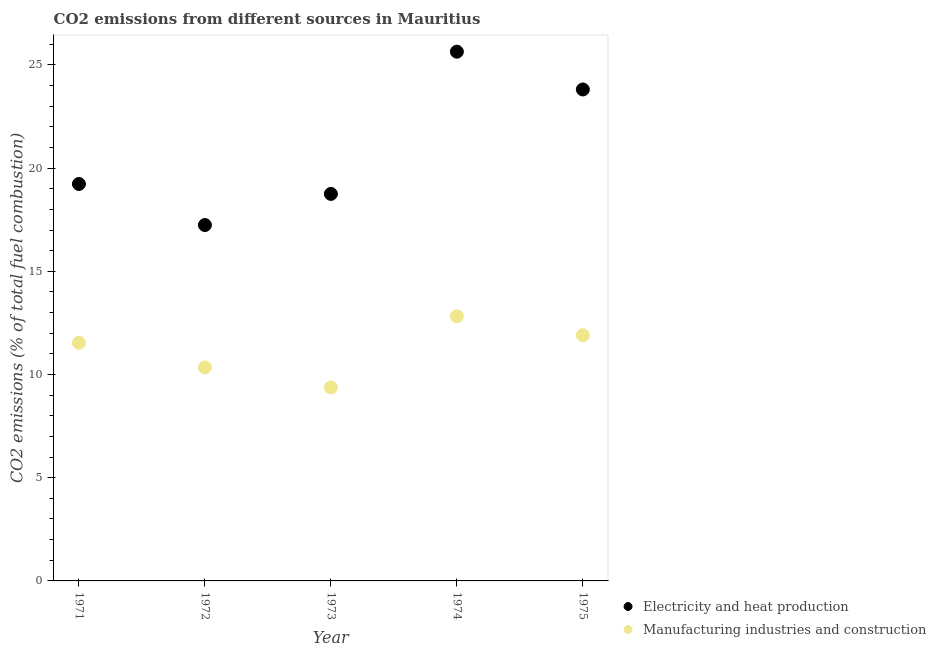How many different coloured dotlines are there?
Make the answer very short. 2. What is the co2 emissions due to manufacturing industries in 1972?
Ensure brevity in your answer.  10.34. Across all years, what is the maximum co2 emissions due to electricity and heat production?
Provide a succinct answer. 25.64. Across all years, what is the minimum co2 emissions due to electricity and heat production?
Ensure brevity in your answer.  17.24. In which year was the co2 emissions due to manufacturing industries maximum?
Give a very brief answer. 1974. What is the total co2 emissions due to electricity and heat production in the graph?
Offer a terse response. 104.67. What is the difference between the co2 emissions due to manufacturing industries in 1971 and that in 1975?
Give a very brief answer. -0.37. What is the difference between the co2 emissions due to manufacturing industries in 1974 and the co2 emissions due to electricity and heat production in 1971?
Provide a succinct answer. -6.41. What is the average co2 emissions due to electricity and heat production per year?
Your answer should be very brief. 20.93. In the year 1974, what is the difference between the co2 emissions due to electricity and heat production and co2 emissions due to manufacturing industries?
Your response must be concise. 12.82. In how many years, is the co2 emissions due to manufacturing industries greater than 17 %?
Your answer should be compact. 0. What is the ratio of the co2 emissions due to electricity and heat production in 1971 to that in 1975?
Offer a very short reply. 0.81. Is the difference between the co2 emissions due to electricity and heat production in 1972 and 1973 greater than the difference between the co2 emissions due to manufacturing industries in 1972 and 1973?
Provide a short and direct response. No. What is the difference between the highest and the second highest co2 emissions due to manufacturing industries?
Make the answer very short. 0.92. What is the difference between the highest and the lowest co2 emissions due to manufacturing industries?
Provide a short and direct response. 3.45. In how many years, is the co2 emissions due to manufacturing industries greater than the average co2 emissions due to manufacturing industries taken over all years?
Ensure brevity in your answer.  3. Is the co2 emissions due to manufacturing industries strictly greater than the co2 emissions due to electricity and heat production over the years?
Ensure brevity in your answer.  No. How many dotlines are there?
Keep it short and to the point. 2. How many years are there in the graph?
Keep it short and to the point. 5. What is the title of the graph?
Your answer should be compact. CO2 emissions from different sources in Mauritius. What is the label or title of the Y-axis?
Provide a short and direct response. CO2 emissions (% of total fuel combustion). What is the CO2 emissions (% of total fuel combustion) of Electricity and heat production in 1971?
Provide a short and direct response. 19.23. What is the CO2 emissions (% of total fuel combustion) in Manufacturing industries and construction in 1971?
Keep it short and to the point. 11.54. What is the CO2 emissions (% of total fuel combustion) in Electricity and heat production in 1972?
Your answer should be compact. 17.24. What is the CO2 emissions (% of total fuel combustion) in Manufacturing industries and construction in 1972?
Make the answer very short. 10.34. What is the CO2 emissions (% of total fuel combustion) of Electricity and heat production in 1973?
Your answer should be compact. 18.75. What is the CO2 emissions (% of total fuel combustion) of Manufacturing industries and construction in 1973?
Make the answer very short. 9.38. What is the CO2 emissions (% of total fuel combustion) of Electricity and heat production in 1974?
Ensure brevity in your answer.  25.64. What is the CO2 emissions (% of total fuel combustion) of Manufacturing industries and construction in 1974?
Offer a very short reply. 12.82. What is the CO2 emissions (% of total fuel combustion) in Electricity and heat production in 1975?
Ensure brevity in your answer.  23.81. What is the CO2 emissions (% of total fuel combustion) of Manufacturing industries and construction in 1975?
Provide a succinct answer. 11.9. Across all years, what is the maximum CO2 emissions (% of total fuel combustion) of Electricity and heat production?
Give a very brief answer. 25.64. Across all years, what is the maximum CO2 emissions (% of total fuel combustion) in Manufacturing industries and construction?
Make the answer very short. 12.82. Across all years, what is the minimum CO2 emissions (% of total fuel combustion) of Electricity and heat production?
Your answer should be very brief. 17.24. Across all years, what is the minimum CO2 emissions (% of total fuel combustion) in Manufacturing industries and construction?
Keep it short and to the point. 9.38. What is the total CO2 emissions (% of total fuel combustion) of Electricity and heat production in the graph?
Your response must be concise. 104.67. What is the total CO2 emissions (% of total fuel combustion) in Manufacturing industries and construction in the graph?
Your response must be concise. 55.98. What is the difference between the CO2 emissions (% of total fuel combustion) of Electricity and heat production in 1971 and that in 1972?
Your answer should be compact. 1.99. What is the difference between the CO2 emissions (% of total fuel combustion) in Manufacturing industries and construction in 1971 and that in 1972?
Your answer should be compact. 1.19. What is the difference between the CO2 emissions (% of total fuel combustion) in Electricity and heat production in 1971 and that in 1973?
Make the answer very short. 0.48. What is the difference between the CO2 emissions (% of total fuel combustion) in Manufacturing industries and construction in 1971 and that in 1973?
Provide a succinct answer. 2.16. What is the difference between the CO2 emissions (% of total fuel combustion) of Electricity and heat production in 1971 and that in 1974?
Your answer should be compact. -6.41. What is the difference between the CO2 emissions (% of total fuel combustion) of Manufacturing industries and construction in 1971 and that in 1974?
Your answer should be very brief. -1.28. What is the difference between the CO2 emissions (% of total fuel combustion) of Electricity and heat production in 1971 and that in 1975?
Offer a terse response. -4.58. What is the difference between the CO2 emissions (% of total fuel combustion) in Manufacturing industries and construction in 1971 and that in 1975?
Keep it short and to the point. -0.37. What is the difference between the CO2 emissions (% of total fuel combustion) of Electricity and heat production in 1972 and that in 1973?
Your answer should be compact. -1.51. What is the difference between the CO2 emissions (% of total fuel combustion) in Manufacturing industries and construction in 1972 and that in 1973?
Make the answer very short. 0.97. What is the difference between the CO2 emissions (% of total fuel combustion) of Electricity and heat production in 1972 and that in 1974?
Your response must be concise. -8.4. What is the difference between the CO2 emissions (% of total fuel combustion) in Manufacturing industries and construction in 1972 and that in 1974?
Keep it short and to the point. -2.48. What is the difference between the CO2 emissions (% of total fuel combustion) in Electricity and heat production in 1972 and that in 1975?
Give a very brief answer. -6.57. What is the difference between the CO2 emissions (% of total fuel combustion) in Manufacturing industries and construction in 1972 and that in 1975?
Keep it short and to the point. -1.56. What is the difference between the CO2 emissions (% of total fuel combustion) of Electricity and heat production in 1973 and that in 1974?
Your answer should be very brief. -6.89. What is the difference between the CO2 emissions (% of total fuel combustion) of Manufacturing industries and construction in 1973 and that in 1974?
Offer a terse response. -3.45. What is the difference between the CO2 emissions (% of total fuel combustion) in Electricity and heat production in 1973 and that in 1975?
Ensure brevity in your answer.  -5.06. What is the difference between the CO2 emissions (% of total fuel combustion) in Manufacturing industries and construction in 1973 and that in 1975?
Your answer should be compact. -2.53. What is the difference between the CO2 emissions (% of total fuel combustion) of Electricity and heat production in 1974 and that in 1975?
Ensure brevity in your answer.  1.83. What is the difference between the CO2 emissions (% of total fuel combustion) in Manufacturing industries and construction in 1974 and that in 1975?
Give a very brief answer. 0.92. What is the difference between the CO2 emissions (% of total fuel combustion) in Electricity and heat production in 1971 and the CO2 emissions (% of total fuel combustion) in Manufacturing industries and construction in 1972?
Offer a very short reply. 8.89. What is the difference between the CO2 emissions (% of total fuel combustion) of Electricity and heat production in 1971 and the CO2 emissions (% of total fuel combustion) of Manufacturing industries and construction in 1973?
Keep it short and to the point. 9.86. What is the difference between the CO2 emissions (% of total fuel combustion) of Electricity and heat production in 1971 and the CO2 emissions (% of total fuel combustion) of Manufacturing industries and construction in 1974?
Give a very brief answer. 6.41. What is the difference between the CO2 emissions (% of total fuel combustion) in Electricity and heat production in 1971 and the CO2 emissions (% of total fuel combustion) in Manufacturing industries and construction in 1975?
Your answer should be compact. 7.33. What is the difference between the CO2 emissions (% of total fuel combustion) of Electricity and heat production in 1972 and the CO2 emissions (% of total fuel combustion) of Manufacturing industries and construction in 1973?
Provide a short and direct response. 7.87. What is the difference between the CO2 emissions (% of total fuel combustion) in Electricity and heat production in 1972 and the CO2 emissions (% of total fuel combustion) in Manufacturing industries and construction in 1974?
Your answer should be compact. 4.42. What is the difference between the CO2 emissions (% of total fuel combustion) of Electricity and heat production in 1972 and the CO2 emissions (% of total fuel combustion) of Manufacturing industries and construction in 1975?
Your answer should be compact. 5.34. What is the difference between the CO2 emissions (% of total fuel combustion) of Electricity and heat production in 1973 and the CO2 emissions (% of total fuel combustion) of Manufacturing industries and construction in 1974?
Offer a terse response. 5.93. What is the difference between the CO2 emissions (% of total fuel combustion) of Electricity and heat production in 1973 and the CO2 emissions (% of total fuel combustion) of Manufacturing industries and construction in 1975?
Your answer should be very brief. 6.85. What is the difference between the CO2 emissions (% of total fuel combustion) of Electricity and heat production in 1974 and the CO2 emissions (% of total fuel combustion) of Manufacturing industries and construction in 1975?
Offer a very short reply. 13.74. What is the average CO2 emissions (% of total fuel combustion) in Electricity and heat production per year?
Give a very brief answer. 20.93. What is the average CO2 emissions (% of total fuel combustion) in Manufacturing industries and construction per year?
Provide a succinct answer. 11.2. In the year 1971, what is the difference between the CO2 emissions (% of total fuel combustion) of Electricity and heat production and CO2 emissions (% of total fuel combustion) of Manufacturing industries and construction?
Offer a terse response. 7.69. In the year 1972, what is the difference between the CO2 emissions (% of total fuel combustion) in Electricity and heat production and CO2 emissions (% of total fuel combustion) in Manufacturing industries and construction?
Offer a terse response. 6.9. In the year 1973, what is the difference between the CO2 emissions (% of total fuel combustion) in Electricity and heat production and CO2 emissions (% of total fuel combustion) in Manufacturing industries and construction?
Keep it short and to the point. 9.38. In the year 1974, what is the difference between the CO2 emissions (% of total fuel combustion) of Electricity and heat production and CO2 emissions (% of total fuel combustion) of Manufacturing industries and construction?
Offer a very short reply. 12.82. In the year 1975, what is the difference between the CO2 emissions (% of total fuel combustion) in Electricity and heat production and CO2 emissions (% of total fuel combustion) in Manufacturing industries and construction?
Give a very brief answer. 11.9. What is the ratio of the CO2 emissions (% of total fuel combustion) of Electricity and heat production in 1971 to that in 1972?
Your response must be concise. 1.12. What is the ratio of the CO2 emissions (% of total fuel combustion) of Manufacturing industries and construction in 1971 to that in 1972?
Provide a short and direct response. 1.12. What is the ratio of the CO2 emissions (% of total fuel combustion) in Electricity and heat production in 1971 to that in 1973?
Give a very brief answer. 1.03. What is the ratio of the CO2 emissions (% of total fuel combustion) of Manufacturing industries and construction in 1971 to that in 1973?
Make the answer very short. 1.23. What is the ratio of the CO2 emissions (% of total fuel combustion) in Electricity and heat production in 1971 to that in 1974?
Offer a terse response. 0.75. What is the ratio of the CO2 emissions (% of total fuel combustion) in Manufacturing industries and construction in 1971 to that in 1974?
Keep it short and to the point. 0.9. What is the ratio of the CO2 emissions (% of total fuel combustion) of Electricity and heat production in 1971 to that in 1975?
Provide a succinct answer. 0.81. What is the ratio of the CO2 emissions (% of total fuel combustion) in Manufacturing industries and construction in 1971 to that in 1975?
Make the answer very short. 0.97. What is the ratio of the CO2 emissions (% of total fuel combustion) in Electricity and heat production in 1972 to that in 1973?
Provide a short and direct response. 0.92. What is the ratio of the CO2 emissions (% of total fuel combustion) of Manufacturing industries and construction in 1972 to that in 1973?
Make the answer very short. 1.1. What is the ratio of the CO2 emissions (% of total fuel combustion) in Electricity and heat production in 1972 to that in 1974?
Ensure brevity in your answer.  0.67. What is the ratio of the CO2 emissions (% of total fuel combustion) of Manufacturing industries and construction in 1972 to that in 1974?
Provide a succinct answer. 0.81. What is the ratio of the CO2 emissions (% of total fuel combustion) of Electricity and heat production in 1972 to that in 1975?
Offer a terse response. 0.72. What is the ratio of the CO2 emissions (% of total fuel combustion) in Manufacturing industries and construction in 1972 to that in 1975?
Make the answer very short. 0.87. What is the ratio of the CO2 emissions (% of total fuel combustion) of Electricity and heat production in 1973 to that in 1974?
Make the answer very short. 0.73. What is the ratio of the CO2 emissions (% of total fuel combustion) in Manufacturing industries and construction in 1973 to that in 1974?
Provide a short and direct response. 0.73. What is the ratio of the CO2 emissions (% of total fuel combustion) of Electricity and heat production in 1973 to that in 1975?
Your answer should be compact. 0.79. What is the ratio of the CO2 emissions (% of total fuel combustion) of Manufacturing industries and construction in 1973 to that in 1975?
Keep it short and to the point. 0.79. What is the ratio of the CO2 emissions (% of total fuel combustion) of Electricity and heat production in 1974 to that in 1975?
Your answer should be compact. 1.08. What is the difference between the highest and the second highest CO2 emissions (% of total fuel combustion) of Electricity and heat production?
Your response must be concise. 1.83. What is the difference between the highest and the second highest CO2 emissions (% of total fuel combustion) of Manufacturing industries and construction?
Make the answer very short. 0.92. What is the difference between the highest and the lowest CO2 emissions (% of total fuel combustion) in Electricity and heat production?
Provide a succinct answer. 8.4. What is the difference between the highest and the lowest CO2 emissions (% of total fuel combustion) in Manufacturing industries and construction?
Your answer should be very brief. 3.45. 